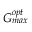Convert formula to latex. <formula><loc_0><loc_0><loc_500><loc_500>G _ { \max } ^ { o p t }</formula> 